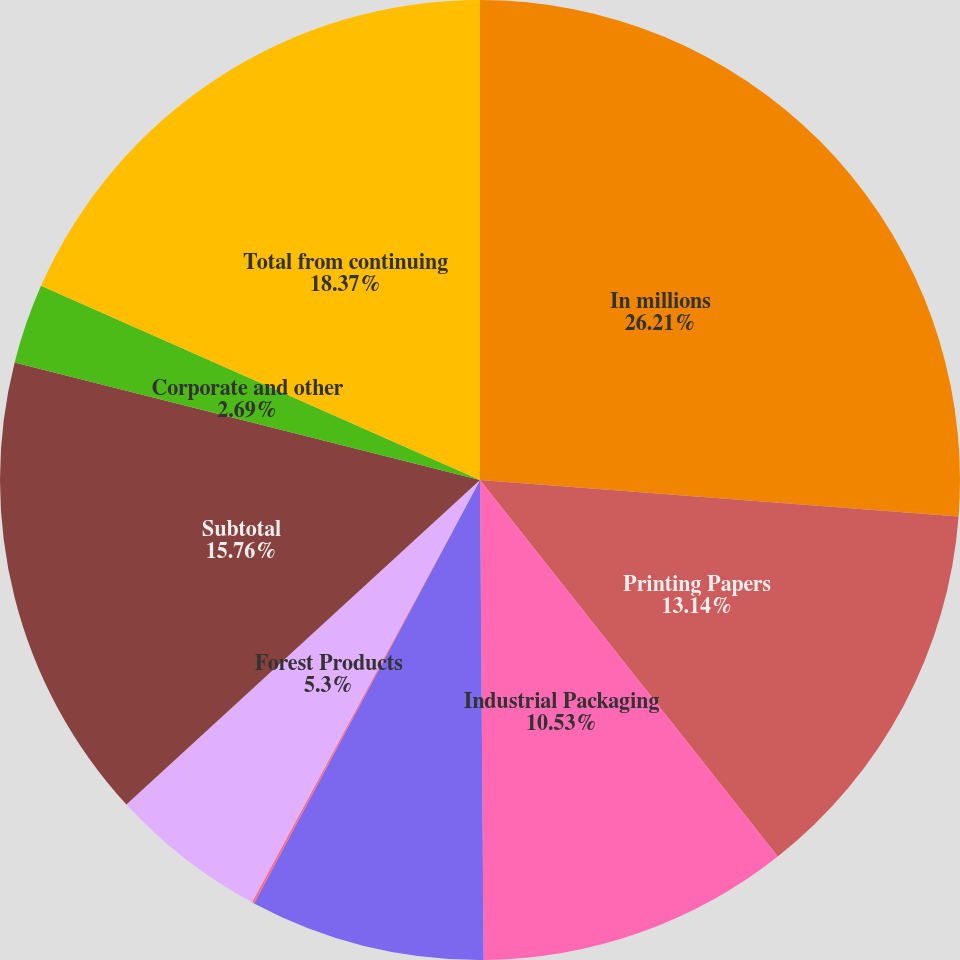Convert chart. <chart><loc_0><loc_0><loc_500><loc_500><pie_chart><fcel>In millions<fcel>Printing Papers<fcel>Industrial Packaging<fcel>Consumer Packaging<fcel>Distribution<fcel>Forest Products<fcel>Subtotal<fcel>Corporate and other<fcel>Total from continuing<nl><fcel>26.21%<fcel>13.14%<fcel>10.53%<fcel>7.92%<fcel>0.08%<fcel>5.3%<fcel>15.76%<fcel>2.69%<fcel>18.37%<nl></chart> 